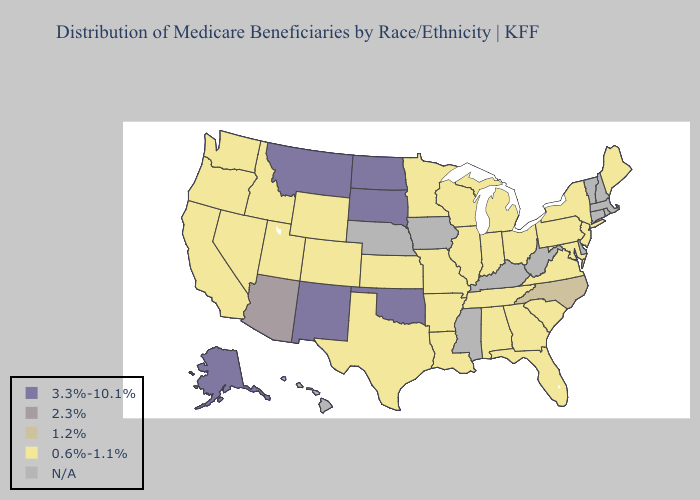Name the states that have a value in the range 3.3%-10.1%?
Concise answer only. Alaska, Montana, New Mexico, North Dakota, Oklahoma, South Dakota. Does Washington have the highest value in the USA?
Short answer required. No. Does the first symbol in the legend represent the smallest category?
Quick response, please. No. Among the states that border Idaho , does Montana have the lowest value?
Quick response, please. No. What is the value of Hawaii?
Write a very short answer. N/A. What is the value of Arizona?
Short answer required. 2.3%. What is the value of Arkansas?
Be succinct. 0.6%-1.1%. Does Illinois have the highest value in the USA?
Quick response, please. No. Does the map have missing data?
Answer briefly. Yes. Name the states that have a value in the range 3.3%-10.1%?
Keep it brief. Alaska, Montana, New Mexico, North Dakota, Oklahoma, South Dakota. Which states have the highest value in the USA?
Be succinct. Alaska, Montana, New Mexico, North Dakota, Oklahoma, South Dakota. Name the states that have a value in the range 0.6%-1.1%?
Answer briefly. Alabama, Arkansas, California, Colorado, Florida, Georgia, Idaho, Illinois, Indiana, Kansas, Louisiana, Maine, Maryland, Michigan, Minnesota, Missouri, Nevada, New Jersey, New York, Ohio, Oregon, Pennsylvania, South Carolina, Tennessee, Texas, Utah, Virginia, Washington, Wisconsin, Wyoming. Which states have the lowest value in the USA?
Give a very brief answer. Alabama, Arkansas, California, Colorado, Florida, Georgia, Idaho, Illinois, Indiana, Kansas, Louisiana, Maine, Maryland, Michigan, Minnesota, Missouri, Nevada, New Jersey, New York, Ohio, Oregon, Pennsylvania, South Carolina, Tennessee, Texas, Utah, Virginia, Washington, Wisconsin, Wyoming. What is the lowest value in the MidWest?
Concise answer only. 0.6%-1.1%. 